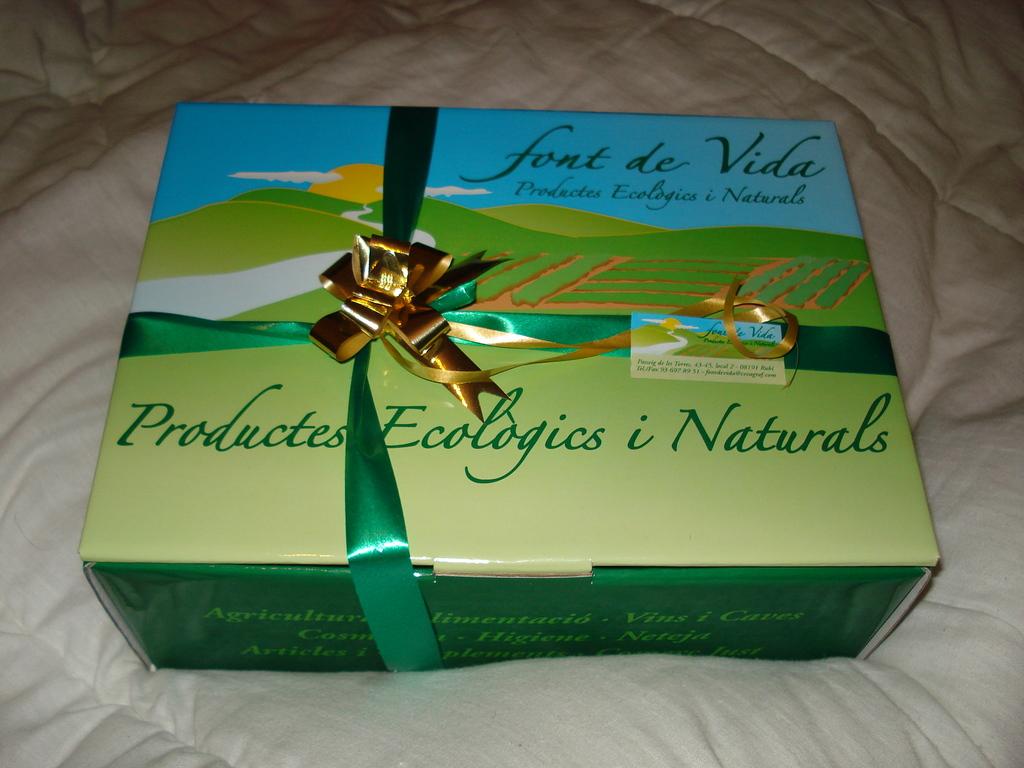What does the box tell us at the top right corner?
Provide a short and direct response. Font de vida. What is the last word in green on the bottom?
Your answer should be very brief. Naturals. 